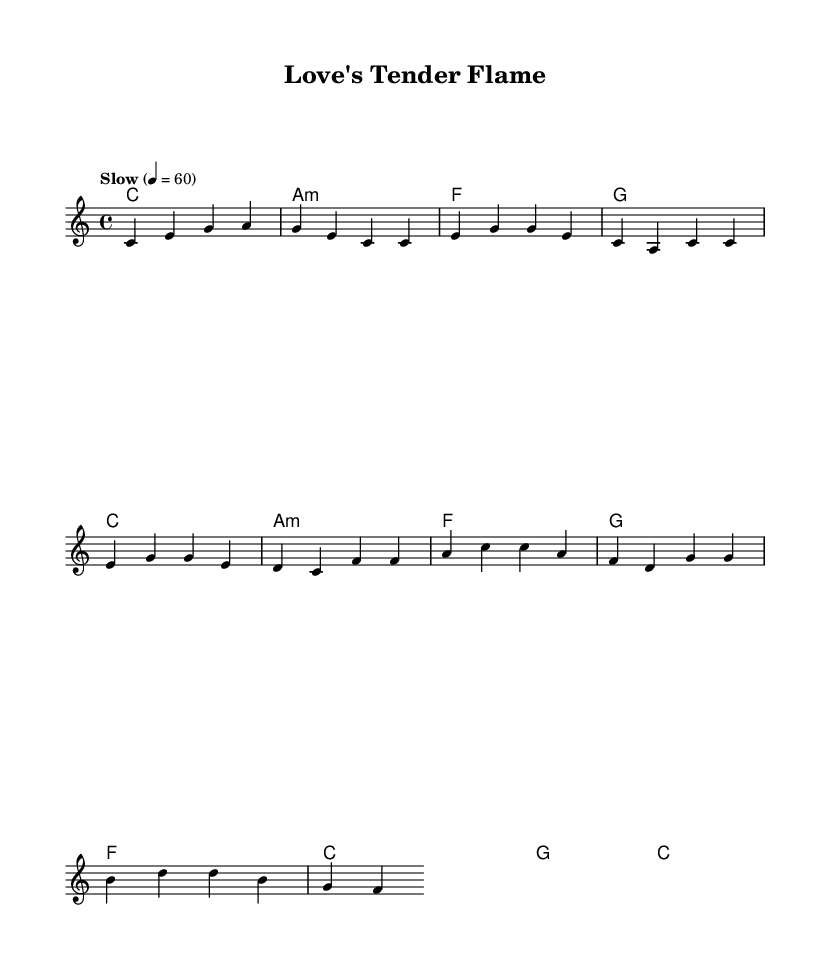What is the key signature of this music? The key signature is C major, which has no sharps or flats.
Answer: C major What is the time signature of this music? The time signature is indicated as 4/4, meaning there are four beats in each measure and the quarter note gets one beat.
Answer: 4/4 What is the tempo marking indicated in the sheet music? The tempo is marked as "Slow" with a metronome marking of 60, indicating a slow, steady pace of 60 beats per minute.
Answer: Slow How many measures are there in the introduction? The introduction consists of one measure with a chord progression that leads into the verse.
Answer: 1 Which chord follows the first C major chord in the verse? After the first C major chord, the next chord is A minor, as shown in the chord progression for that section.
Answer: A minor What type of musical piece is this based on its elements? This piece is categorized as a pop ballad, as indicated by its melody structure, lyrics' emotional quality, and the overall nostalgic feel reminiscent of Elvis's love songs.
Answer: Pop ballad What is the last chord of the chorus? The last chord in the chorus is C major, indicating a resolution after the preceding progression.
Answer: C 